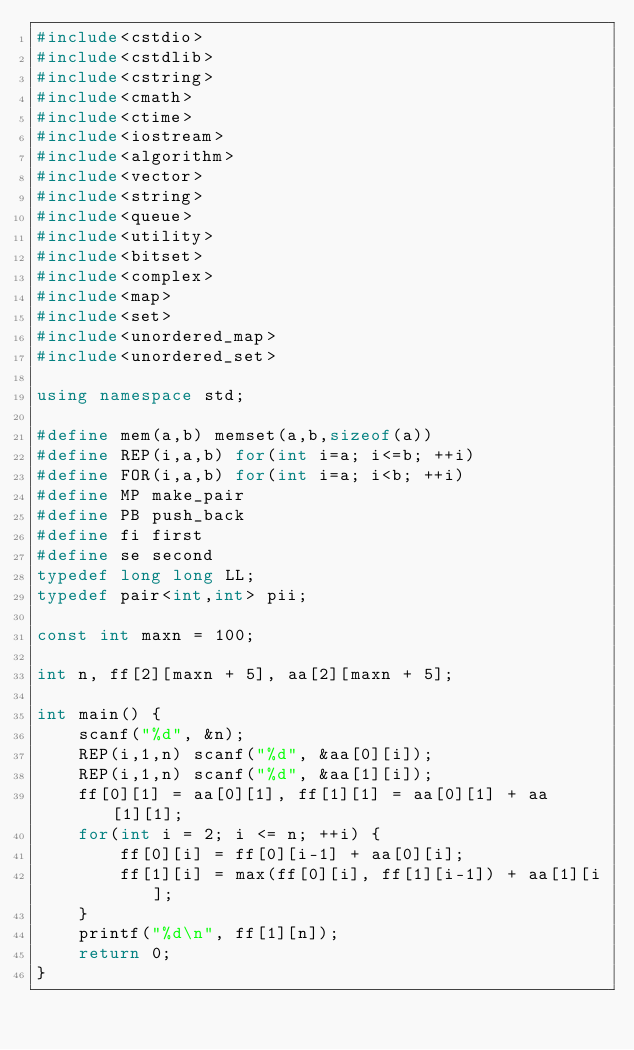Convert code to text. <code><loc_0><loc_0><loc_500><loc_500><_C++_>#include<cstdio>
#include<cstdlib>
#include<cstring>
#include<cmath>
#include<ctime>
#include<iostream>
#include<algorithm>
#include<vector>
#include<string>
#include<queue>
#include<utility>
#include<bitset>
#include<complex>
#include<map>
#include<set>
#include<unordered_map>
#include<unordered_set>

using namespace std;

#define mem(a,b) memset(a,b,sizeof(a))
#define REP(i,a,b) for(int i=a; i<=b; ++i)
#define FOR(i,a,b) for(int i=a; i<b; ++i)
#define MP make_pair
#define PB push_back
#define fi first
#define se second
typedef long long LL;
typedef pair<int,int> pii;

const int maxn = 100;

int n, ff[2][maxn + 5], aa[2][maxn + 5];

int main() {
    scanf("%d", &n);
    REP(i,1,n) scanf("%d", &aa[0][i]);
    REP(i,1,n) scanf("%d", &aa[1][i]);
    ff[0][1] = aa[0][1], ff[1][1] = aa[0][1] + aa[1][1];
    for(int i = 2; i <= n; ++i) {
        ff[0][i] = ff[0][i-1] + aa[0][i];
        ff[1][i] = max(ff[0][i], ff[1][i-1]) + aa[1][i];
    }
    printf("%d\n", ff[1][n]);
    return 0;
}
</code> 